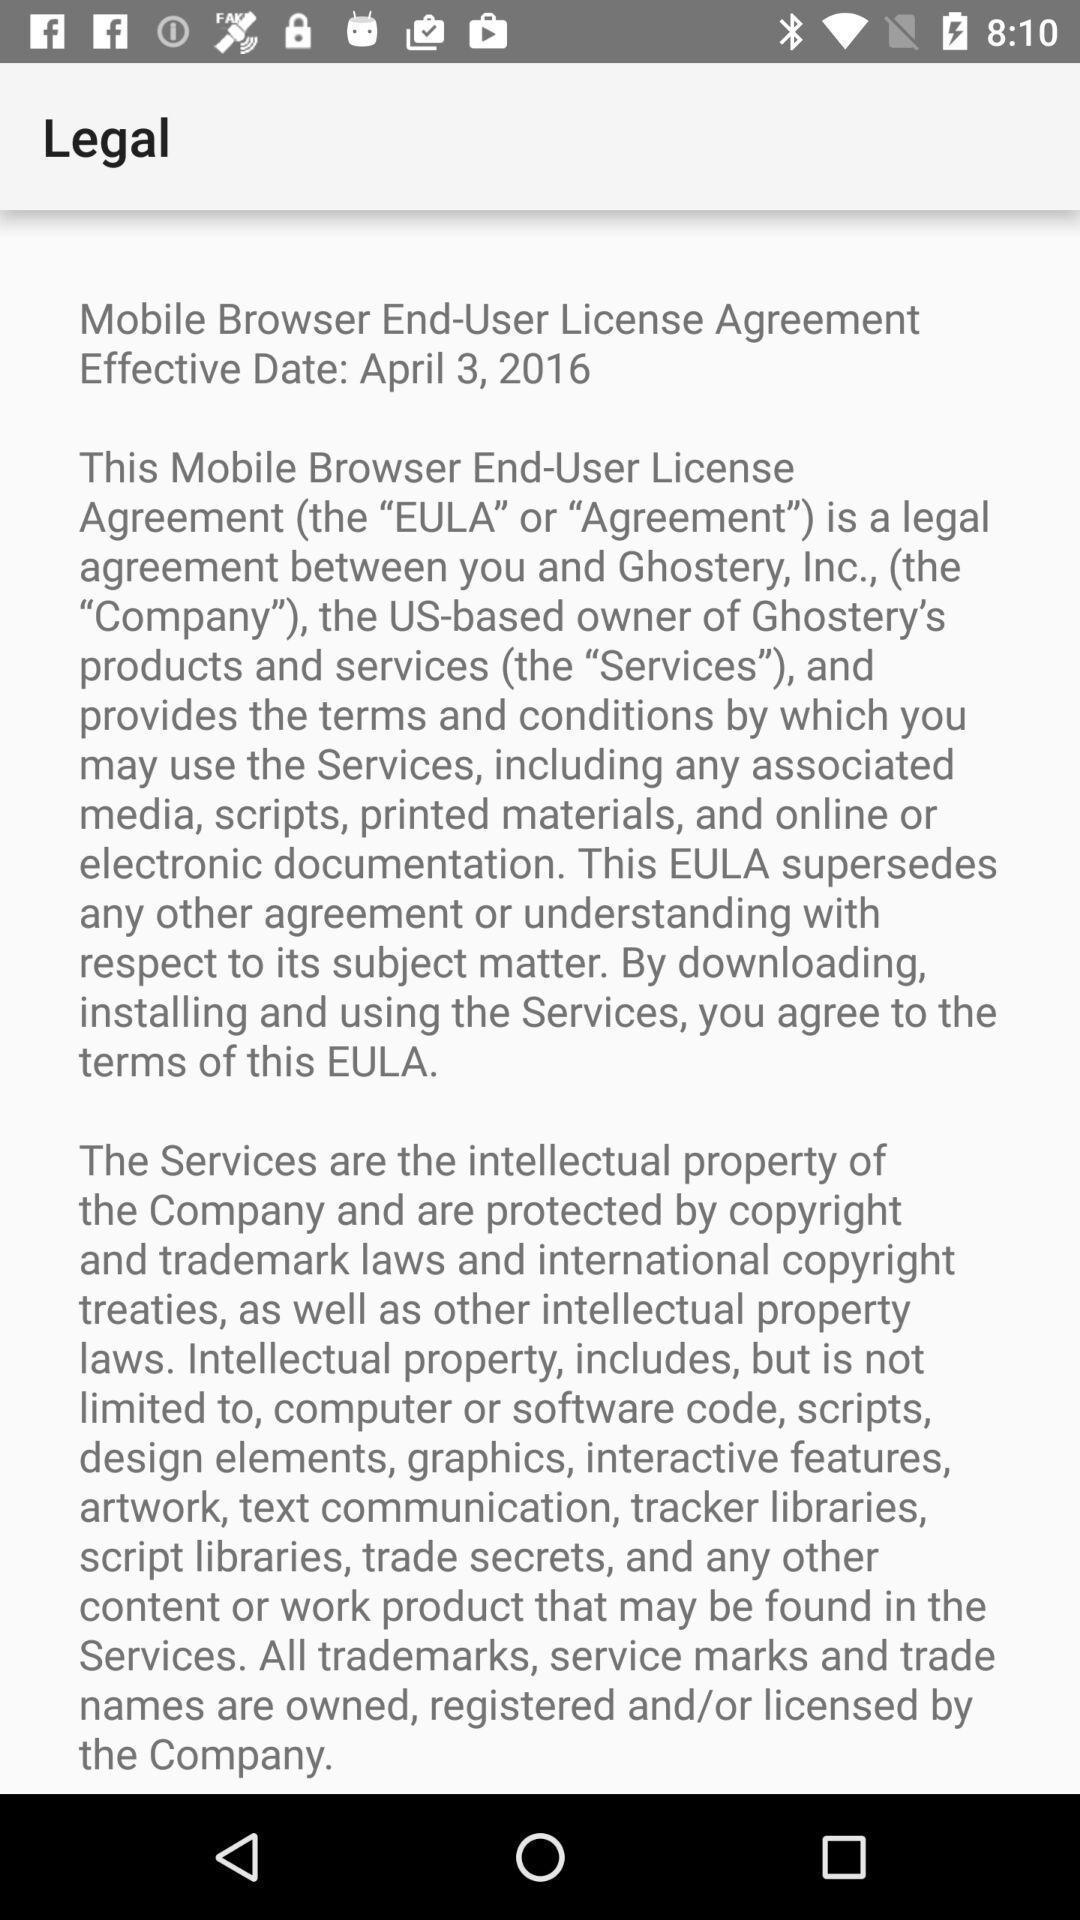Provide a detailed account of this screenshot. Screen displaying legal agreement page. 